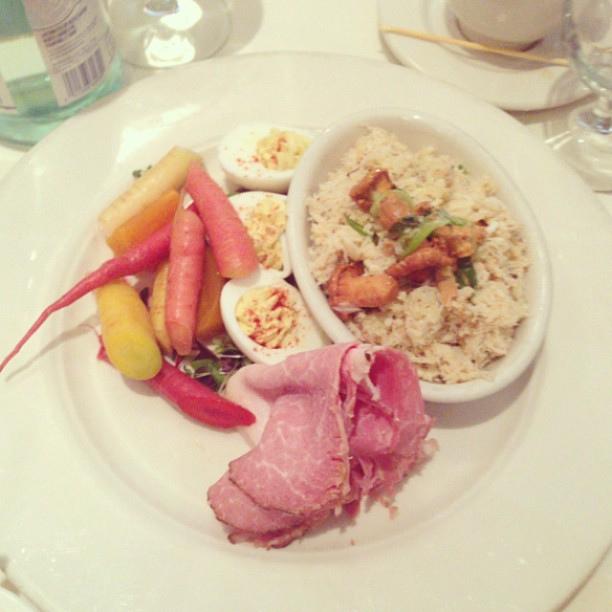Are the eggs served hot or cold?
Answer briefly. Cold. Is there a fork?
Give a very brief answer. No. What vegetables are on the plate?
Quick response, please. Carrots. What color is the plate?
Answer briefly. White. Why did you choose to eat at such a fancy restaurant?
Quick response, please. Hungry. 